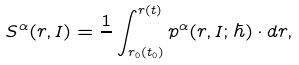<formula> <loc_0><loc_0><loc_500><loc_500>S ^ { \alpha } ( { r } , { I } ) = \frac { 1 } { } \int ^ { { r } ( t ) } _ { { r } _ { 0 } ( t _ { 0 } ) } { p } ^ { \alpha } ( { r } , { I } ; \hbar { ) } \cdot d { r } ,</formula> 